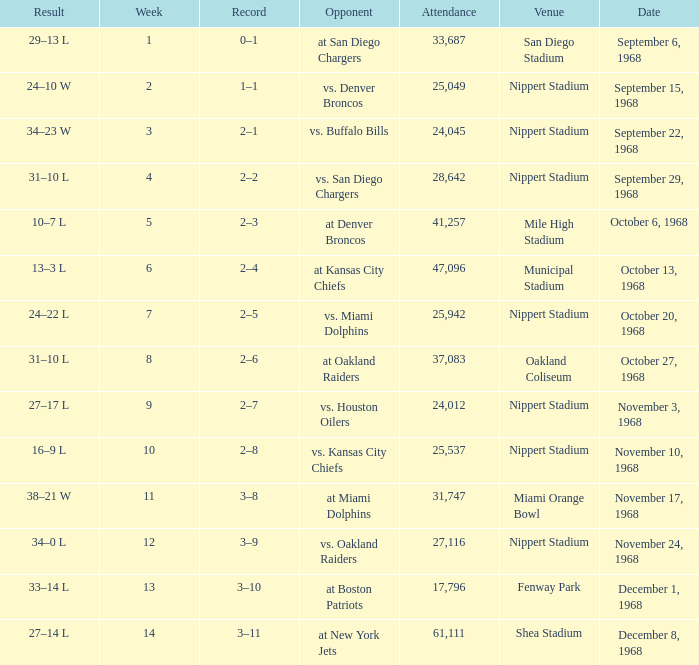What week was the game played at Mile High Stadium? 5.0. 